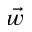Convert formula to latex. <formula><loc_0><loc_0><loc_500><loc_500>\vec { w }</formula> 